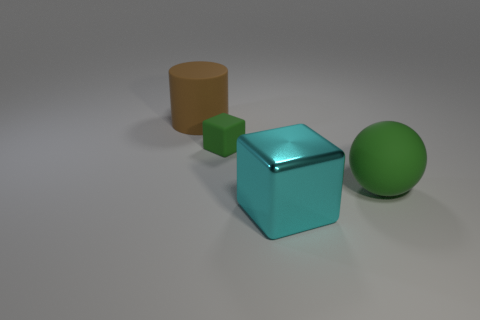The sphere is what size?
Provide a short and direct response. Large. Is the number of cyan metallic things that are in front of the large green thing greater than the number of tiny green rubber things in front of the small thing?
Offer a very short reply. Yes. There is a large object to the left of the small green rubber thing; what number of green balls are in front of it?
Make the answer very short. 1. Is the shape of the green thing that is on the right side of the big shiny cube the same as  the small matte thing?
Offer a very short reply. No. There is another object that is the same shape as the tiny green matte object; what material is it?
Provide a short and direct response. Metal. How many brown things have the same size as the sphere?
Your answer should be very brief. 1. The thing that is in front of the green cube and left of the green ball is what color?
Your answer should be very brief. Cyan. Is the number of green rubber objects less than the number of large spheres?
Offer a terse response. No. There is a small block; is it the same color as the large rubber object to the right of the small green block?
Give a very brief answer. Yes. Are there an equal number of big cylinders that are to the left of the brown matte cylinder and matte things to the right of the cyan thing?
Provide a short and direct response. No. 